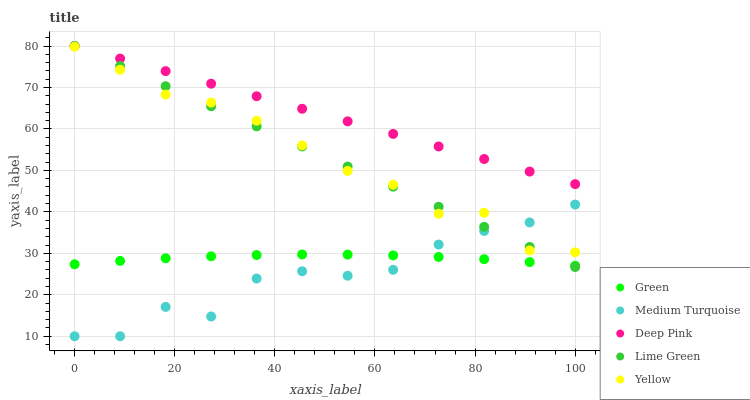Does Medium Turquoise have the minimum area under the curve?
Answer yes or no. Yes. Does Deep Pink have the maximum area under the curve?
Answer yes or no. Yes. Does Green have the minimum area under the curve?
Answer yes or no. No. Does Green have the maximum area under the curve?
Answer yes or no. No. Is Lime Green the smoothest?
Answer yes or no. Yes. Is Medium Turquoise the roughest?
Answer yes or no. Yes. Is Deep Pink the smoothest?
Answer yes or no. No. Is Deep Pink the roughest?
Answer yes or no. No. Does Medium Turquoise have the lowest value?
Answer yes or no. Yes. Does Green have the lowest value?
Answer yes or no. No. Does Deep Pink have the highest value?
Answer yes or no. Yes. Does Green have the highest value?
Answer yes or no. No. Is Green less than Yellow?
Answer yes or no. Yes. Is Deep Pink greater than Medium Turquoise?
Answer yes or no. Yes. Does Deep Pink intersect Lime Green?
Answer yes or no. Yes. Is Deep Pink less than Lime Green?
Answer yes or no. No. Is Deep Pink greater than Lime Green?
Answer yes or no. No. Does Green intersect Yellow?
Answer yes or no. No. 